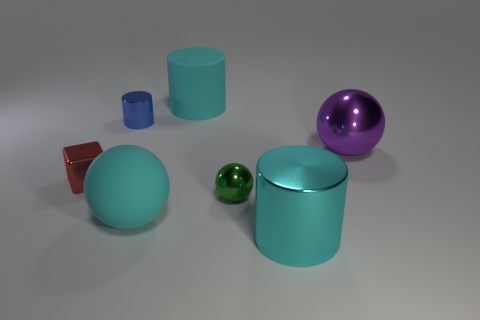Subtract all big cyan rubber cylinders. How many cylinders are left? 2 Add 3 green metallic spheres. How many objects exist? 10 Subtract all spheres. How many objects are left? 4 Add 2 red blocks. How many red blocks exist? 3 Subtract 0 gray cylinders. How many objects are left? 7 Subtract all tiny green blocks. Subtract all purple things. How many objects are left? 6 Add 6 cyan cylinders. How many cyan cylinders are left? 8 